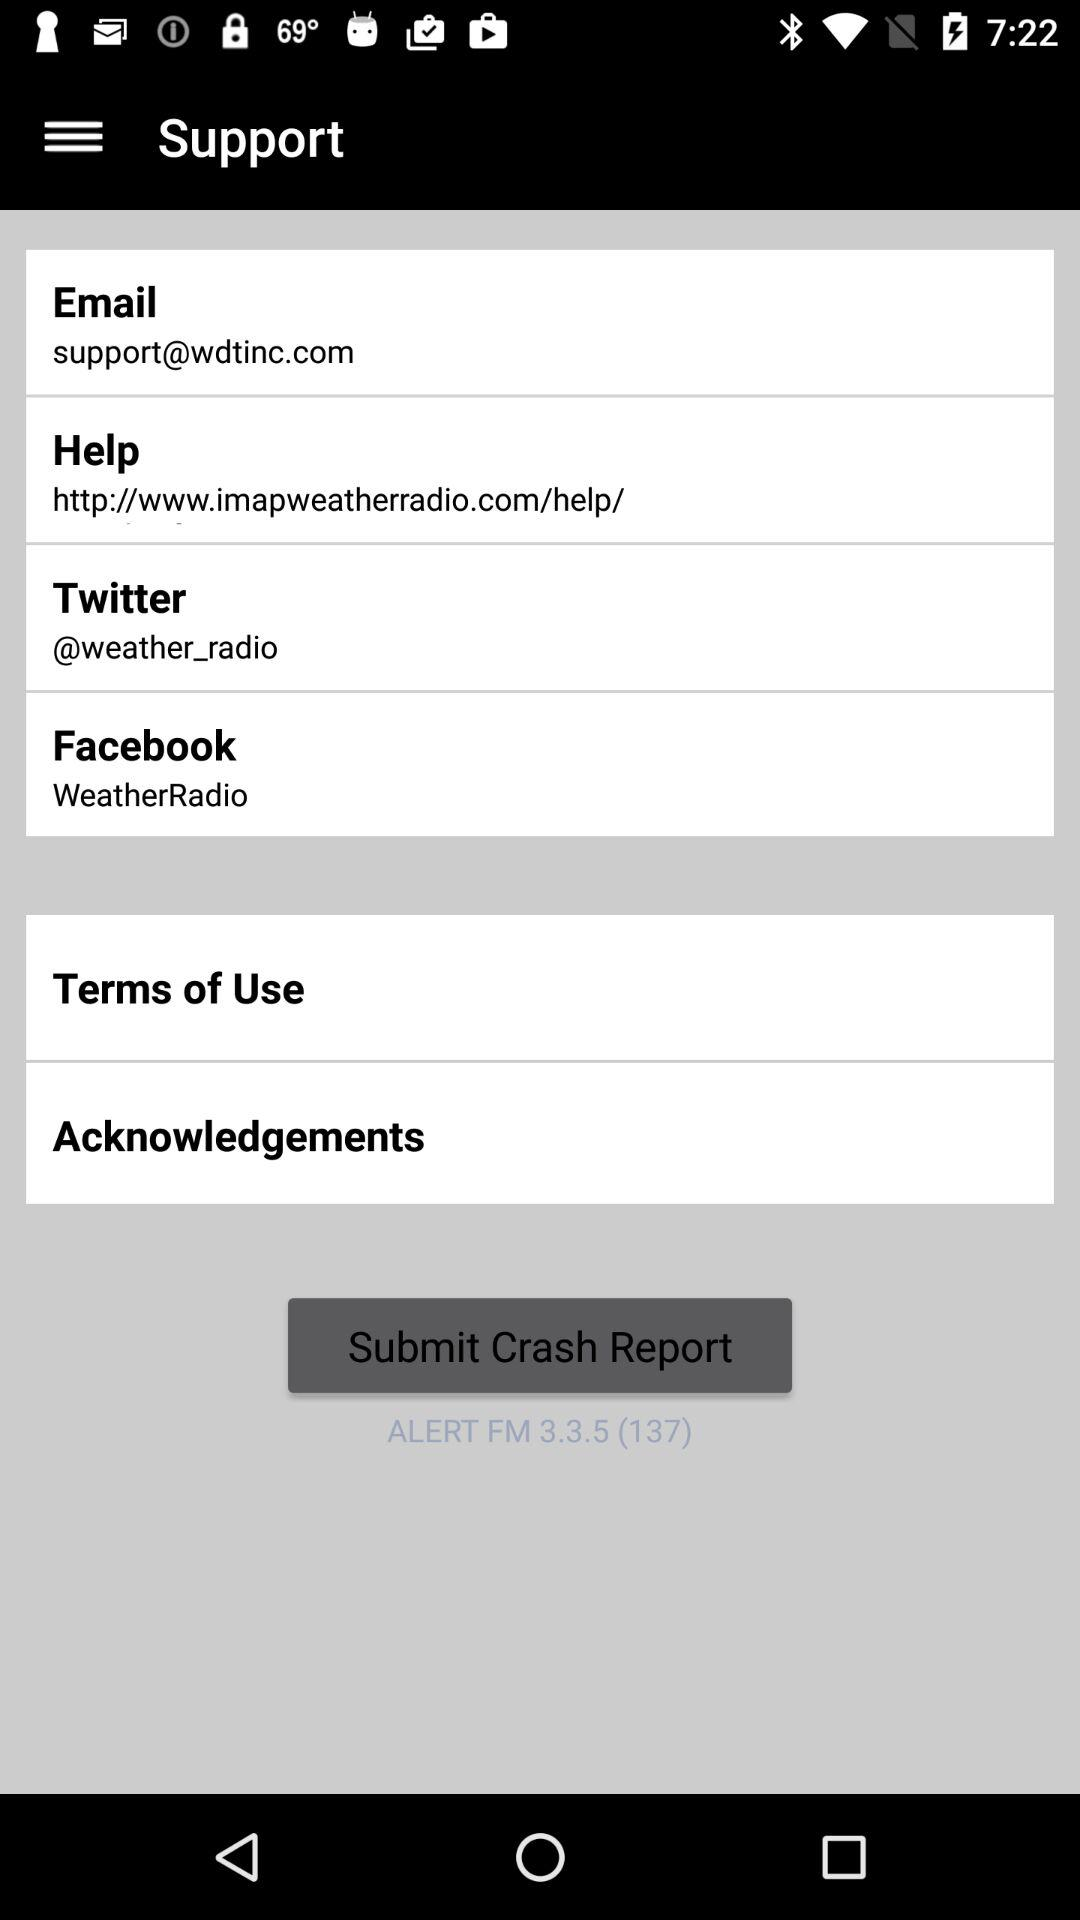What is the "Help" link? The link is "http://www.imapweatherradio.com/help/". 